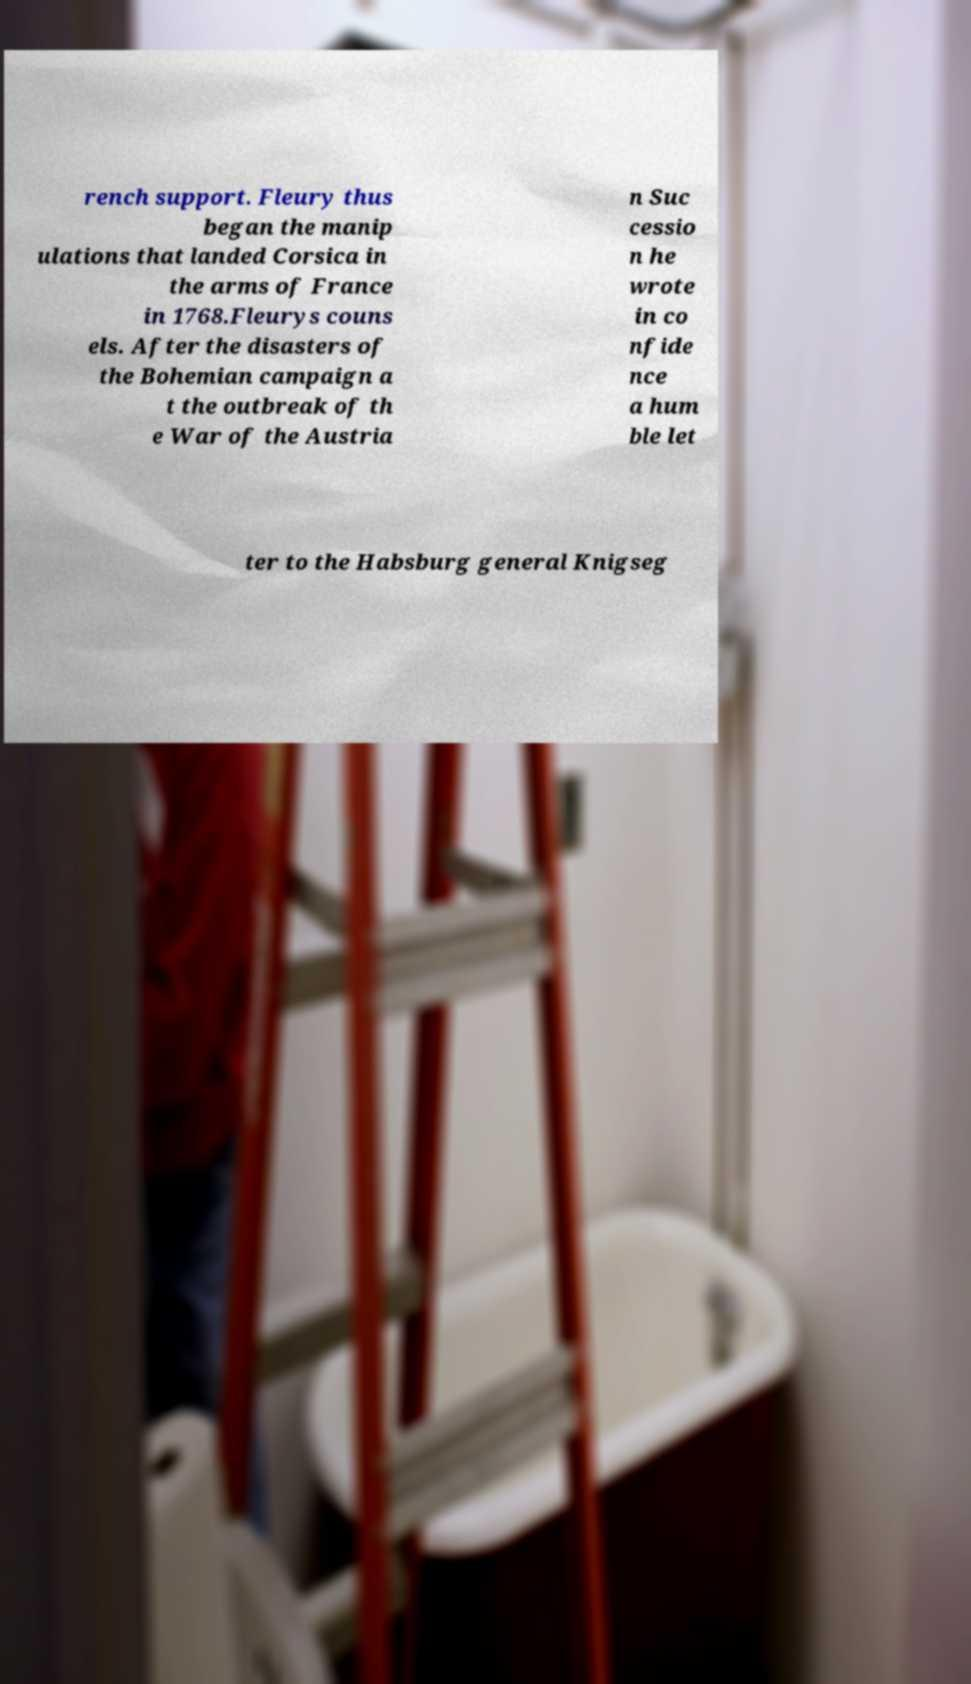What messages or text are displayed in this image? I need them in a readable, typed format. rench support. Fleury thus began the manip ulations that landed Corsica in the arms of France in 1768.Fleurys couns els. After the disasters of the Bohemian campaign a t the outbreak of th e War of the Austria n Suc cessio n he wrote in co nfide nce a hum ble let ter to the Habsburg general Knigseg 